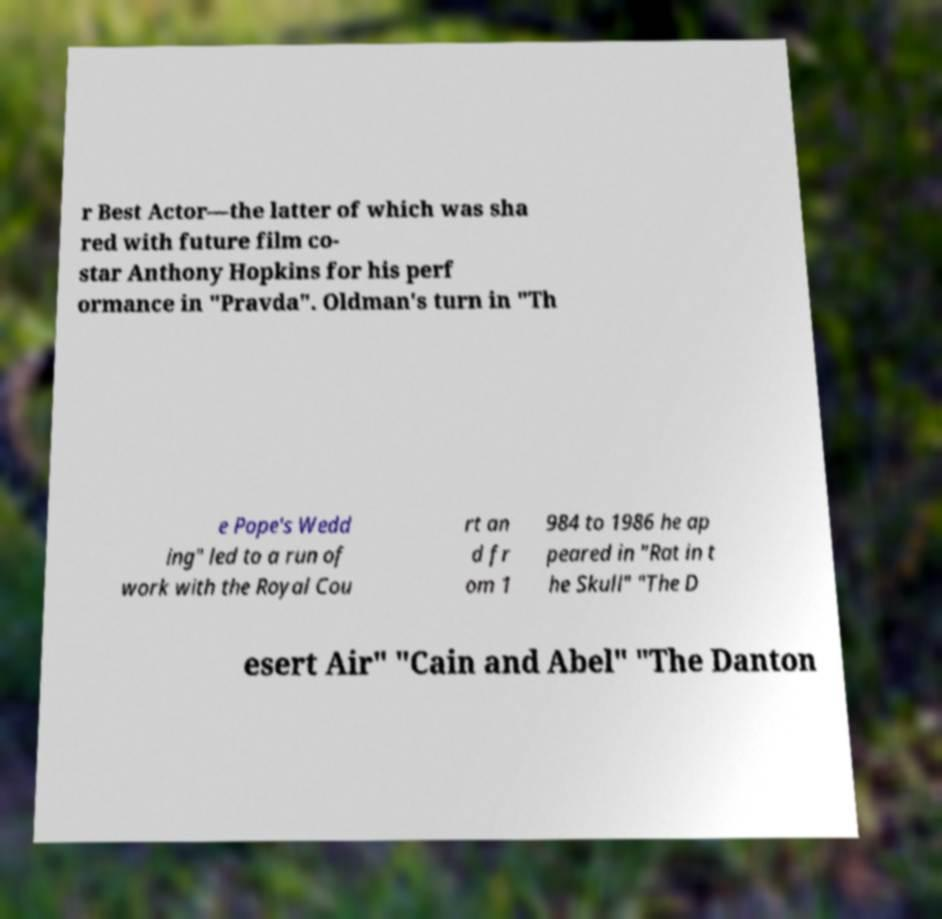What messages or text are displayed in this image? I need them in a readable, typed format. r Best Actor—the latter of which was sha red with future film co- star Anthony Hopkins for his perf ormance in "Pravda". Oldman's turn in "Th e Pope's Wedd ing" led to a run of work with the Royal Cou rt an d fr om 1 984 to 1986 he ap peared in "Rat in t he Skull" "The D esert Air" "Cain and Abel" "The Danton 